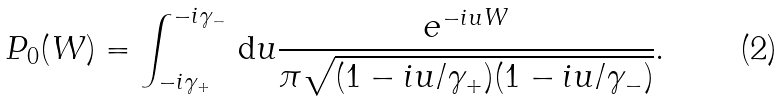Convert formula to latex. <formula><loc_0><loc_0><loc_500><loc_500>P _ { 0 } ( W ) = \int _ { - i \gamma _ { + } } ^ { - i \gamma _ { - } } \, \mathrm d u \frac { e ^ { - i u W } } { \pi \sqrt { ( 1 - i u / \gamma _ { + } ) ( 1 - i u / \gamma _ { - } ) } } .</formula> 